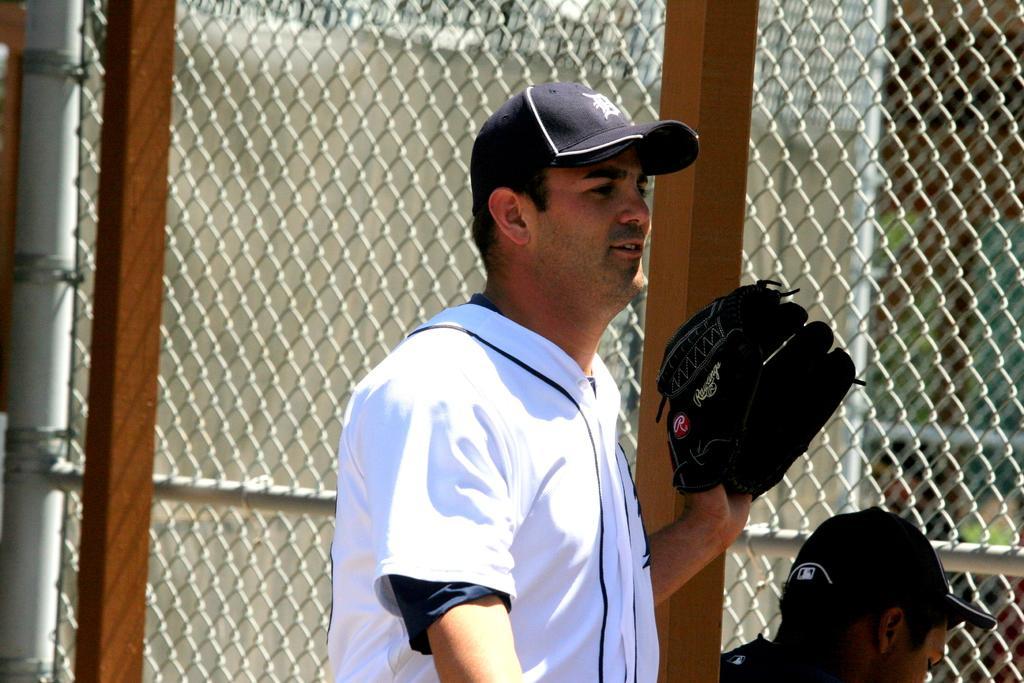Could you give a brief overview of what you see in this image? In this picture we can see a man in the white t shirt with a black cap and behind the man there is another man, fence, pole, wall and other things. 